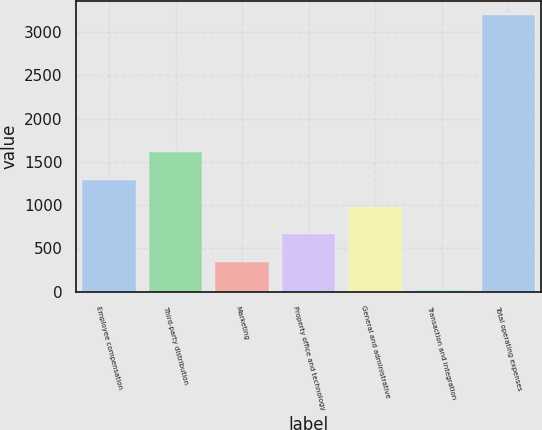<chart> <loc_0><loc_0><loc_500><loc_500><bar_chart><fcel>Employee compensation<fcel>Third-party distribution<fcel>Marketing<fcel>Property office and technology<fcel>General and administrative<fcel>Transaction and integration<fcel>Total operating expenses<nl><fcel>1295.28<fcel>1611.75<fcel>345.87<fcel>662.34<fcel>978.81<fcel>29.4<fcel>3194.1<nl></chart> 